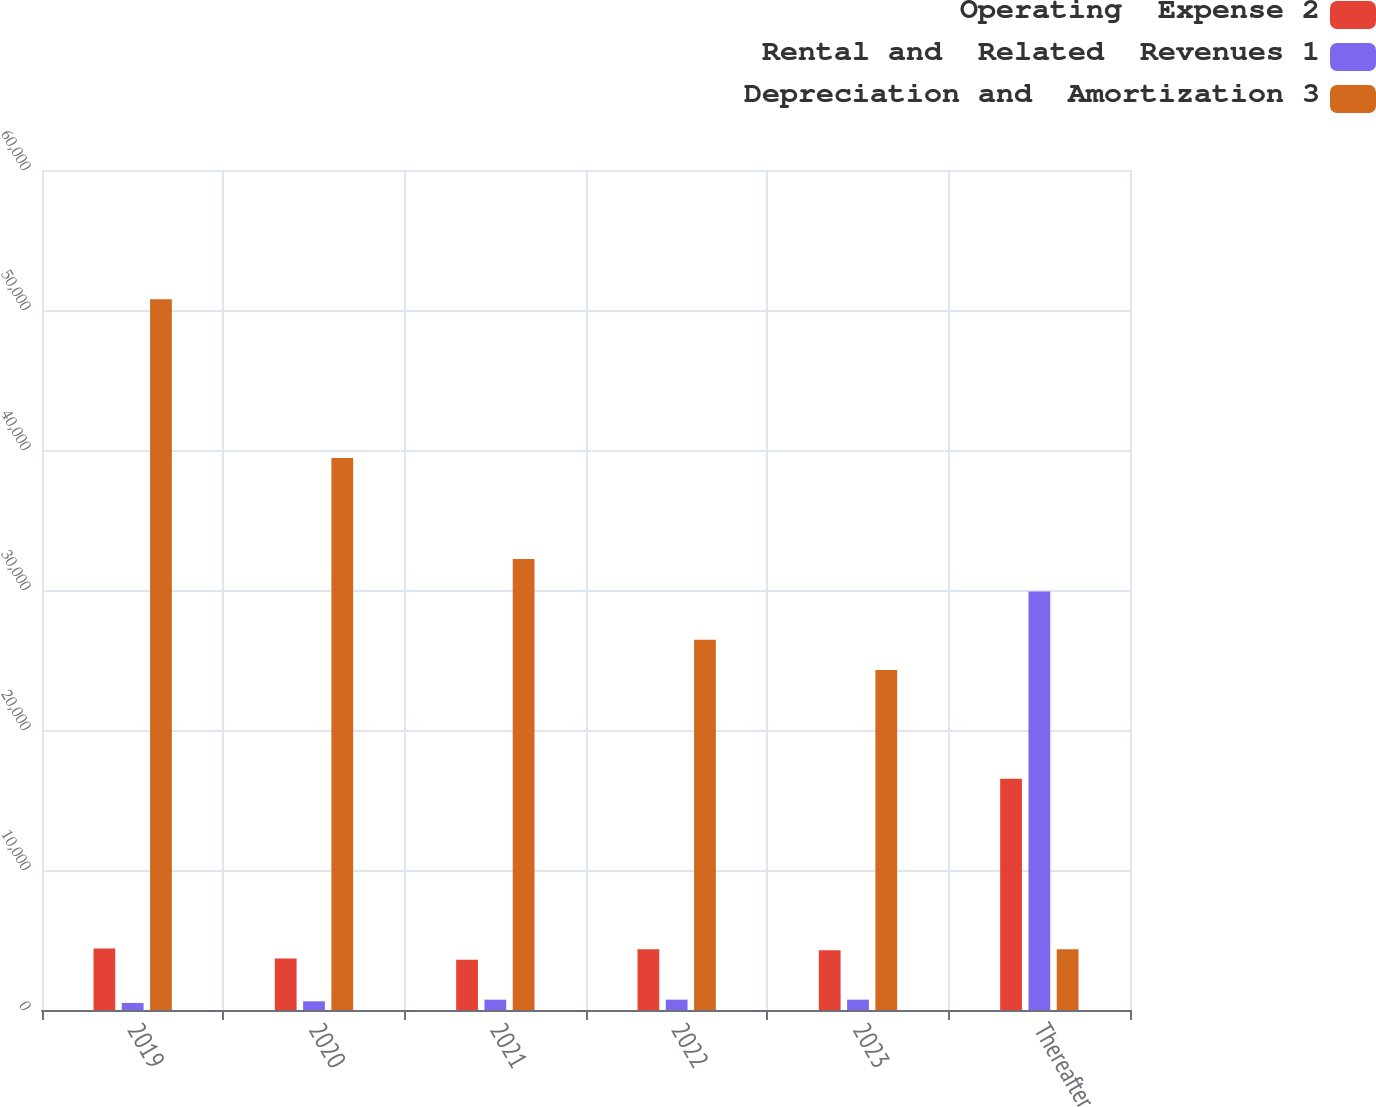Convert chart to OTSL. <chart><loc_0><loc_0><loc_500><loc_500><stacked_bar_chart><ecel><fcel>2019<fcel>2020<fcel>2021<fcel>2022<fcel>2023<fcel>Thereafter<nl><fcel>Operating  Expense 2<fcel>4399<fcel>3670<fcel>3587<fcel>4331<fcel>4269<fcel>16521<nl><fcel>Rental and  Related  Revenues 1<fcel>505<fcel>621<fcel>738<fcel>738<fcel>738<fcel>29901<nl><fcel>Depreciation and  Amortization 3<fcel>50762<fcel>39433<fcel>32214<fcel>26438<fcel>24293<fcel>4331<nl></chart> 